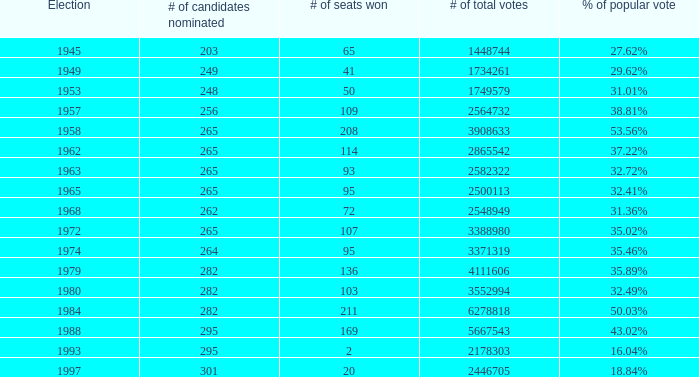How many times was the # of total votes 2582322? 1.0. 